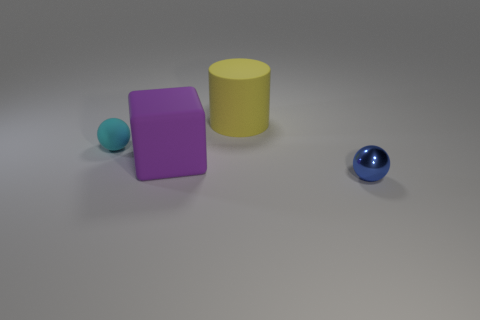Add 1 blue metallic balls. How many objects exist? 5 Subtract all blocks. How many objects are left? 3 Subtract all matte objects. Subtract all big yellow rubber blocks. How many objects are left? 1 Add 3 matte cubes. How many matte cubes are left? 4 Add 2 rubber objects. How many rubber objects exist? 5 Subtract 0 yellow balls. How many objects are left? 4 